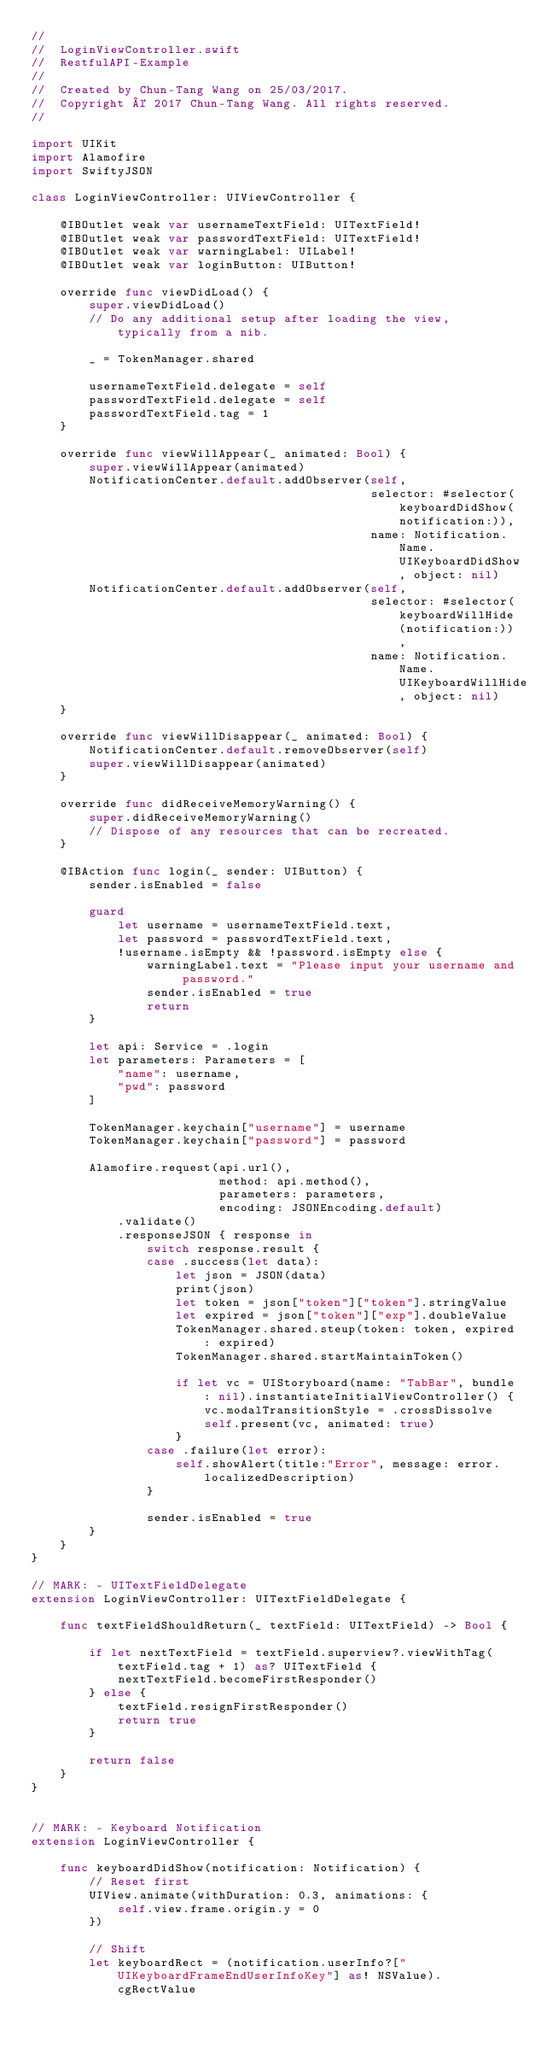Convert code to text. <code><loc_0><loc_0><loc_500><loc_500><_Swift_>//
//  LoginViewController.swift
//  RestfulAPI-Example
//
//  Created by Chun-Tang Wang on 25/03/2017.
//  Copyright © 2017 Chun-Tang Wang. All rights reserved.
//

import UIKit
import Alamofire
import SwiftyJSON

class LoginViewController: UIViewController {

    @IBOutlet weak var usernameTextField: UITextField!
    @IBOutlet weak var passwordTextField: UITextField!
    @IBOutlet weak var warningLabel: UILabel!
    @IBOutlet weak var loginButton: UIButton!
    
    override func viewDidLoad() {
        super.viewDidLoad()
        // Do any additional setup after loading the view, typically from a nib.
        
        _ = TokenManager.shared
        
        usernameTextField.delegate = self
        passwordTextField.delegate = self
        passwordTextField.tag = 1
    }
    
    override func viewWillAppear(_ animated: Bool) {
        super.viewWillAppear(animated)
        NotificationCenter.default.addObserver(self,
                                               selector: #selector(keyboardDidShow(notification:)),
                                               name: Notification.Name.UIKeyboardDidShow, object: nil)
        NotificationCenter.default.addObserver(self,
                                               selector: #selector(keyboardWillHide(notification:)),
                                               name: Notification.Name.UIKeyboardWillHide, object: nil)
    }
    
    override func viewWillDisappear(_ animated: Bool) {
        NotificationCenter.default.removeObserver(self)
        super.viewWillDisappear(animated)
    }

    override func didReceiveMemoryWarning() {
        super.didReceiveMemoryWarning()
        // Dispose of any resources that can be recreated.
    }

    @IBAction func login(_ sender: UIButton) {
        sender.isEnabled = false
        
        guard
            let username = usernameTextField.text,
            let password = passwordTextField.text,
            !username.isEmpty && !password.isEmpty else {
                warningLabel.text = "Please input your username and password."
                sender.isEnabled = true
                return
        }
        
        let api: Service = .login
        let parameters: Parameters = [
            "name": username,
            "pwd": password
        ]
        
        TokenManager.keychain["username"] = username
        TokenManager.keychain["password"] = password
        
        Alamofire.request(api.url(),
                          method: api.method(),
                          parameters: parameters,
                          encoding: JSONEncoding.default)
            .validate()
            .responseJSON { response in
                switch response.result {
                case .success(let data):
                    let json = JSON(data)
                    print(json)
                    let token = json["token"]["token"].stringValue
                    let expired = json["token"]["exp"].doubleValue
                    TokenManager.shared.steup(token: token, expired: expired)
                    TokenManager.shared.startMaintainToken()
                    
                    if let vc = UIStoryboard(name: "TabBar", bundle: nil).instantiateInitialViewController() {
                        vc.modalTransitionStyle = .crossDissolve
                        self.present(vc, animated: true)
                    }
                case .failure(let error):
                    self.showAlert(title:"Error", message: error.localizedDescription)
                }
                
                sender.isEnabled = true
        }
    }
}

// MARK: - UITextFieldDelegate
extension LoginViewController: UITextFieldDelegate {
    
    func textFieldShouldReturn(_ textField: UITextField) -> Bool {
        
        if let nextTextField = textField.superview?.viewWithTag(textField.tag + 1) as? UITextField {
            nextTextField.becomeFirstResponder()
        } else {
            textField.resignFirstResponder()
            return true
        }
        
        return false
    }
}


// MARK: - Keyboard Notification
extension LoginViewController {
    
    func keyboardDidShow(notification: Notification) {
        // Reset first
        UIView.animate(withDuration: 0.3, animations: {
            self.view.frame.origin.y = 0
        })
        
        // Shift
        let keyboardRect = (notification.userInfo?["UIKeyboardFrameEndUserInfoKey"] as! NSValue).cgRectValue
        </code> 